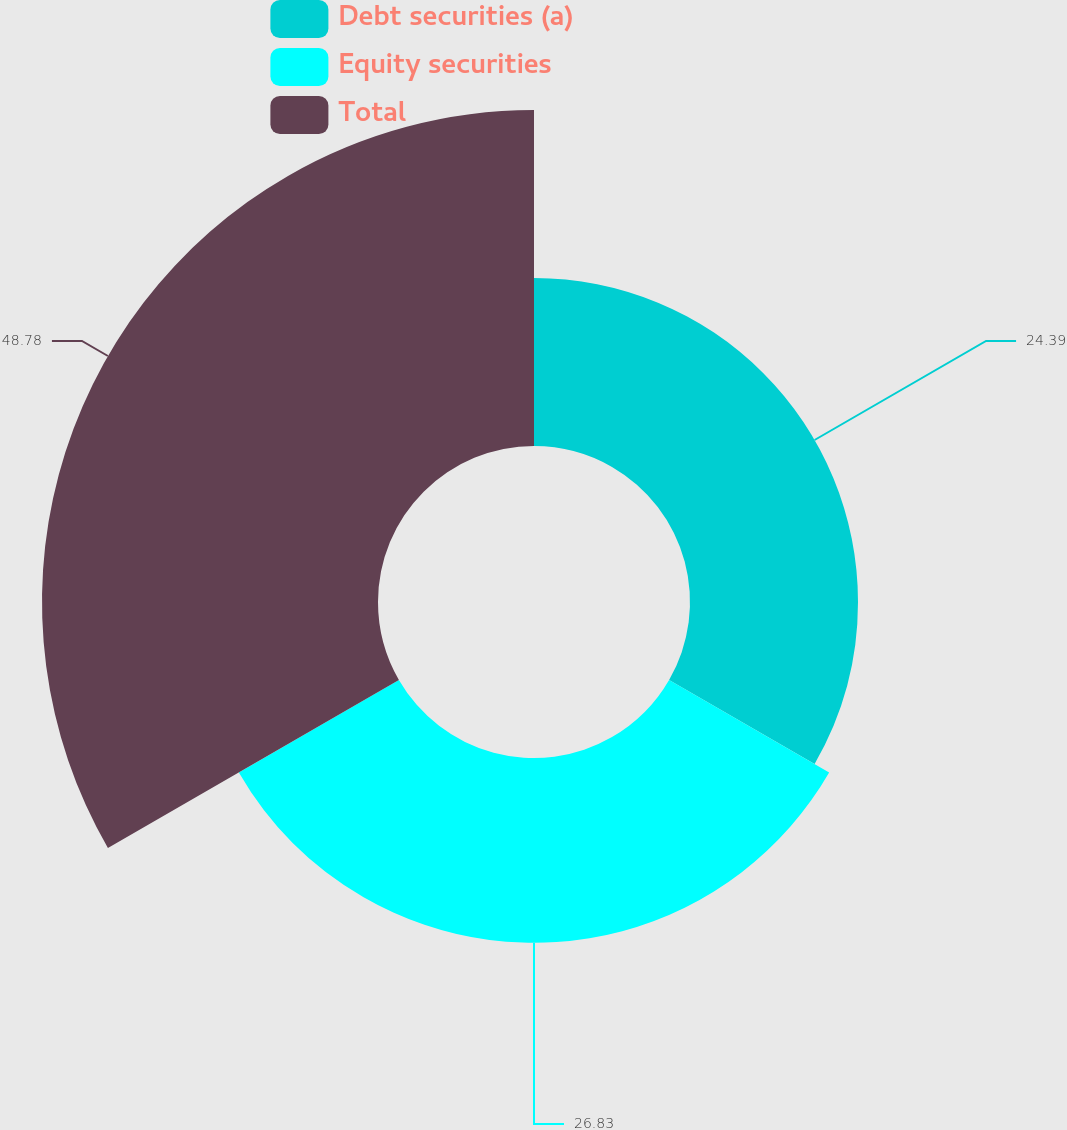Convert chart. <chart><loc_0><loc_0><loc_500><loc_500><pie_chart><fcel>Debt securities (a)<fcel>Equity securities<fcel>Total<nl><fcel>24.39%<fcel>26.83%<fcel>48.78%<nl></chart> 